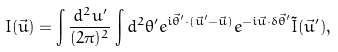<formula> <loc_0><loc_0><loc_500><loc_500>I ( \vec { u } ) = \int \frac { d ^ { 2 } u ^ { \prime } } { ( 2 \pi ) ^ { 2 } } \int d ^ { 2 } \theta ^ { \prime } e ^ { i \vec { \theta } ^ { \prime } \cdot ( \vec { u } ^ { \prime } - \vec { u } ) } e ^ { - i \vec { u } \cdot \delta \vec { \theta } ^ { \prime } } \tilde { I } ( \vec { u } ^ { \prime } ) ,</formula> 